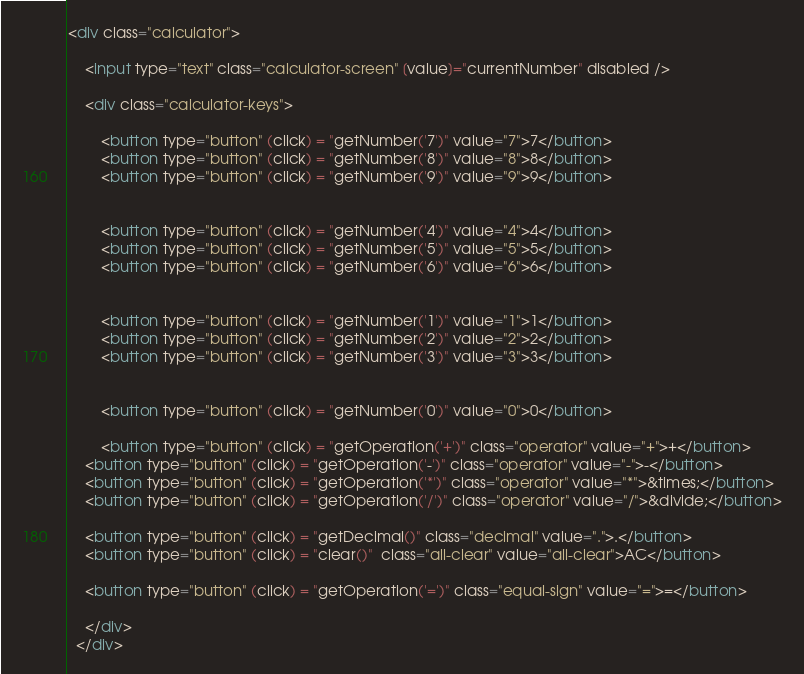<code> <loc_0><loc_0><loc_500><loc_500><_HTML_><div class="calculator">

    <input type="text" class="calculator-screen" [value]="currentNumber" disabled />

    <div class="calculator-keys">
      
        <button type="button" (click) = "getNumber('7')" value="7">7</button>
        <button type="button" (click) = "getNumber('8')" value="8">8</button>
        <button type="button" (click) = "getNumber('9')" value="9">9</button>
    
    
        <button type="button" (click) = "getNumber('4')" value="4">4</button>
        <button type="button" (click) = "getNumber('5')" value="5">5</button>
        <button type="button" (click) = "getNumber('6')" value="6">6</button>
    
    
        <button type="button" (click) = "getNumber('1')" value="1">1</button>
        <button type="button" (click) = "getNumber('2')" value="2">2</button>
        <button type="button" (click) = "getNumber('3')" value="3">3</button>
    
    
        <button type="button" (click) = "getNumber('0')" value="0">0</button>

        <button type="button" (click) = "getOperation('+')" class="operator" value="+">+</button>
    <button type="button" (click) = "getOperation('-')" class="operator" value="-">-</button>
    <button type="button" (click) = "getOperation('*')" class="operator" value="*">&times;</button>
    <button type="button" (click) = "getOperation('/')" class="operator" value="/">&divide;</button>

    <button type="button" (click) = "getDecimal()" class="decimal" value=".">.</button>
    <button type="button" (click) = "clear()"  class="all-clear" value="all-clear">AC</button>

    <button type="button" (click) = "getOperation('=')" class="equal-sign" value="=">=</button>

    </div>
  </div></code> 